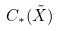Convert formula to latex. <formula><loc_0><loc_0><loc_500><loc_500>C _ { * } ( \tilde { X } )</formula> 